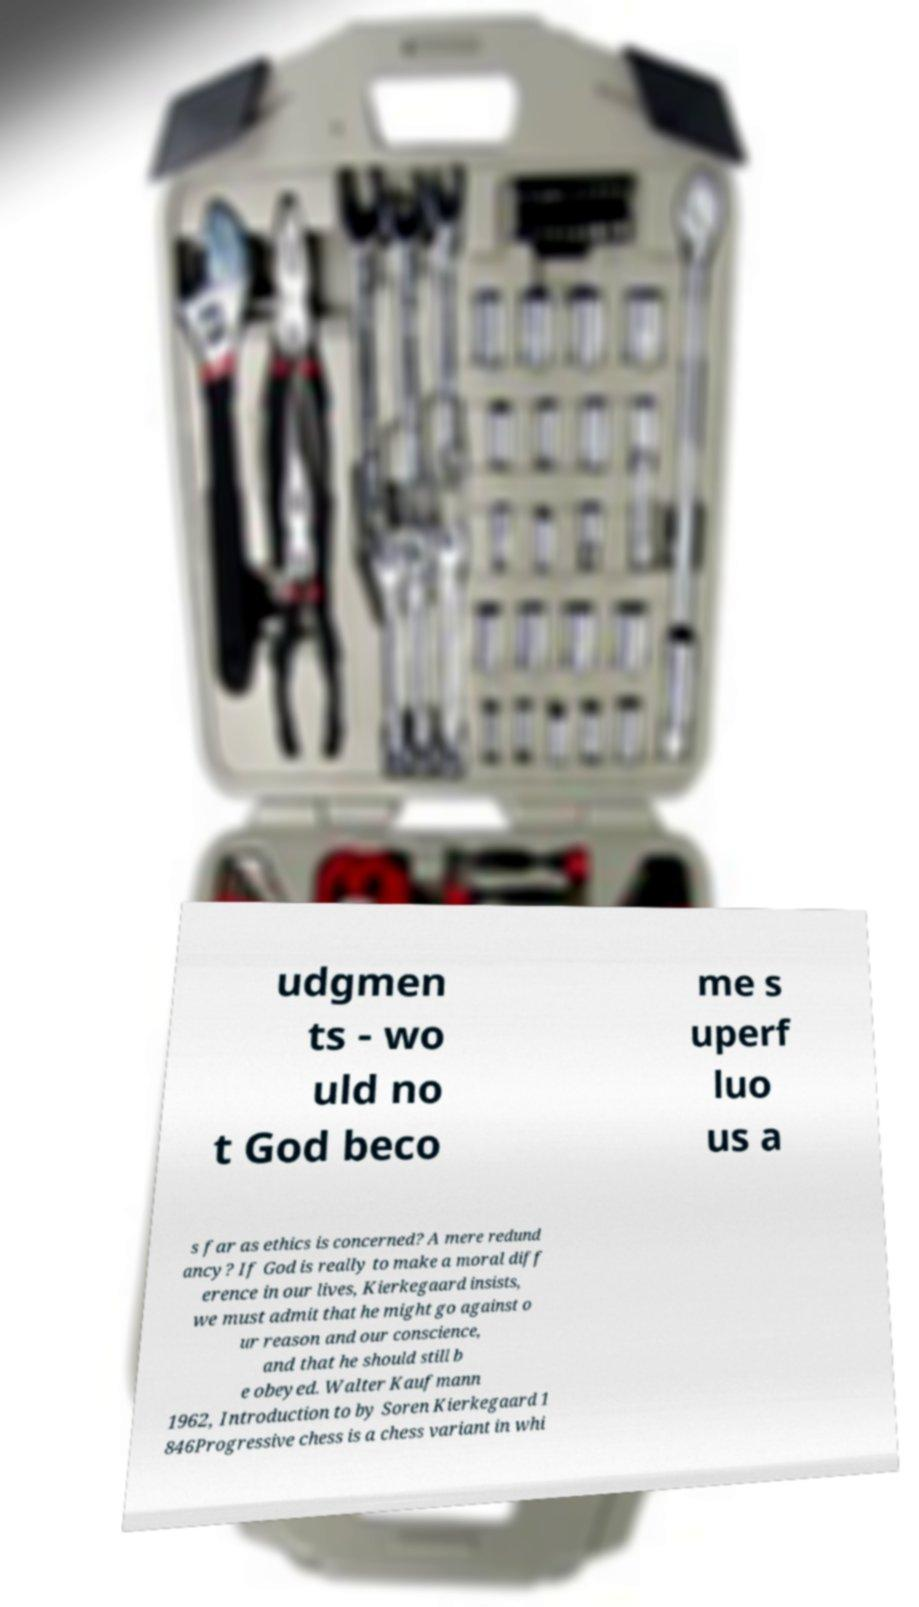Could you extract and type out the text from this image? udgmen ts - wo uld no t God beco me s uperf luo us a s far as ethics is concerned? A mere redund ancy? If God is really to make a moral diff erence in our lives, Kierkegaard insists, we must admit that he might go against o ur reason and our conscience, and that he should still b e obeyed. Walter Kaufmann 1962, Introduction to by Soren Kierkegaard 1 846Progressive chess is a chess variant in whi 